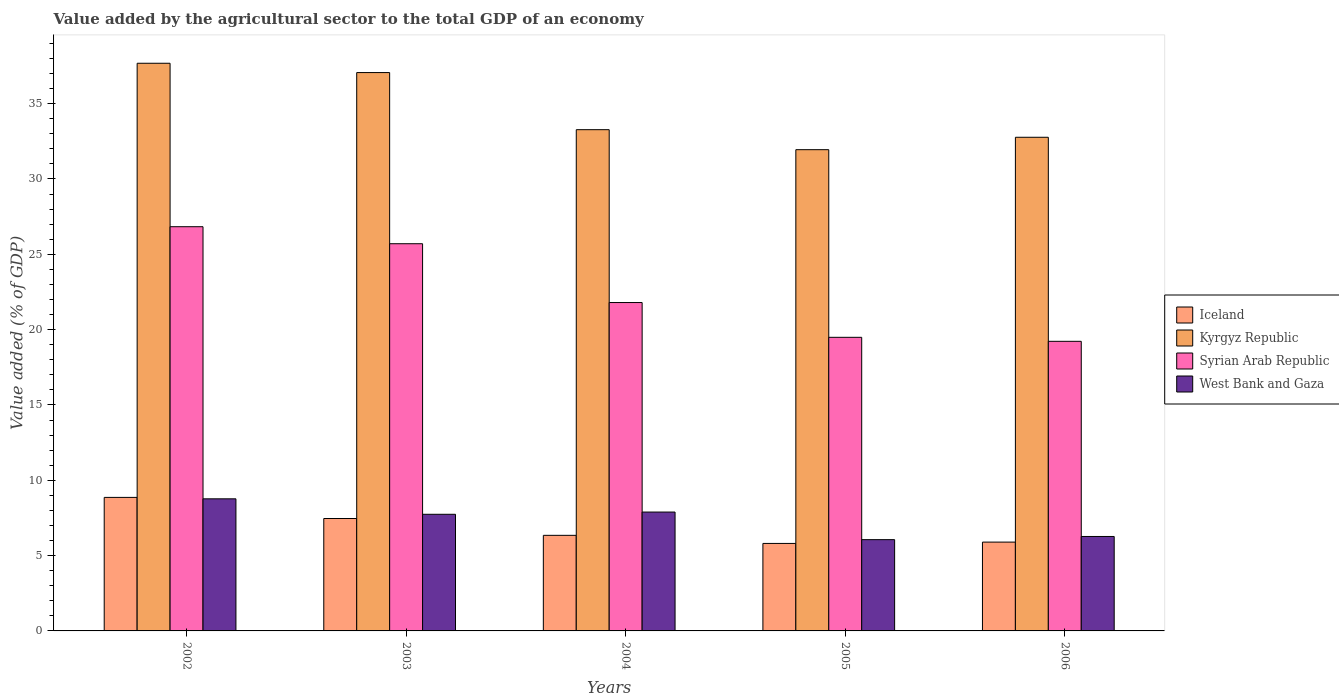How many different coloured bars are there?
Provide a short and direct response. 4. Are the number of bars per tick equal to the number of legend labels?
Make the answer very short. Yes. How many bars are there on the 3rd tick from the right?
Give a very brief answer. 4. What is the label of the 3rd group of bars from the left?
Offer a very short reply. 2004. What is the value added by the agricultural sector to the total GDP in Iceland in 2002?
Offer a terse response. 8.86. Across all years, what is the maximum value added by the agricultural sector to the total GDP in Iceland?
Give a very brief answer. 8.86. Across all years, what is the minimum value added by the agricultural sector to the total GDP in West Bank and Gaza?
Your answer should be very brief. 6.06. In which year was the value added by the agricultural sector to the total GDP in Syrian Arab Republic maximum?
Keep it short and to the point. 2002. What is the total value added by the agricultural sector to the total GDP in Kyrgyz Republic in the graph?
Provide a succinct answer. 172.74. What is the difference between the value added by the agricultural sector to the total GDP in Iceland in 2002 and that in 2003?
Offer a terse response. 1.4. What is the difference between the value added by the agricultural sector to the total GDP in Kyrgyz Republic in 2003 and the value added by the agricultural sector to the total GDP in Syrian Arab Republic in 2004?
Offer a very short reply. 15.27. What is the average value added by the agricultural sector to the total GDP in West Bank and Gaza per year?
Your answer should be very brief. 7.35. In the year 2004, what is the difference between the value added by the agricultural sector to the total GDP in Kyrgyz Republic and value added by the agricultural sector to the total GDP in Syrian Arab Republic?
Offer a very short reply. 11.47. In how many years, is the value added by the agricultural sector to the total GDP in Iceland greater than 3 %?
Offer a very short reply. 5. What is the ratio of the value added by the agricultural sector to the total GDP in Iceland in 2002 to that in 2006?
Make the answer very short. 1.5. Is the difference between the value added by the agricultural sector to the total GDP in Kyrgyz Republic in 2003 and 2006 greater than the difference between the value added by the agricultural sector to the total GDP in Syrian Arab Republic in 2003 and 2006?
Provide a short and direct response. No. What is the difference between the highest and the second highest value added by the agricultural sector to the total GDP in Syrian Arab Republic?
Your answer should be very brief. 1.13. What is the difference between the highest and the lowest value added by the agricultural sector to the total GDP in West Bank and Gaza?
Provide a succinct answer. 2.71. In how many years, is the value added by the agricultural sector to the total GDP in Iceland greater than the average value added by the agricultural sector to the total GDP in Iceland taken over all years?
Give a very brief answer. 2. What does the 3rd bar from the left in 2006 represents?
Provide a short and direct response. Syrian Arab Republic. Is it the case that in every year, the sum of the value added by the agricultural sector to the total GDP in Iceland and value added by the agricultural sector to the total GDP in Kyrgyz Republic is greater than the value added by the agricultural sector to the total GDP in Syrian Arab Republic?
Give a very brief answer. Yes. How many bars are there?
Your answer should be compact. 20. Are all the bars in the graph horizontal?
Offer a very short reply. No. How many years are there in the graph?
Offer a terse response. 5. Does the graph contain any zero values?
Provide a succinct answer. No. Does the graph contain grids?
Ensure brevity in your answer.  No. How many legend labels are there?
Offer a terse response. 4. What is the title of the graph?
Your answer should be compact. Value added by the agricultural sector to the total GDP of an economy. What is the label or title of the X-axis?
Ensure brevity in your answer.  Years. What is the label or title of the Y-axis?
Provide a short and direct response. Value added (% of GDP). What is the Value added (% of GDP) in Iceland in 2002?
Provide a succinct answer. 8.86. What is the Value added (% of GDP) of Kyrgyz Republic in 2002?
Offer a very short reply. 37.68. What is the Value added (% of GDP) of Syrian Arab Republic in 2002?
Provide a succinct answer. 26.83. What is the Value added (% of GDP) of West Bank and Gaza in 2002?
Offer a terse response. 8.77. What is the Value added (% of GDP) of Iceland in 2003?
Keep it short and to the point. 7.46. What is the Value added (% of GDP) in Kyrgyz Republic in 2003?
Your answer should be compact. 37.06. What is the Value added (% of GDP) in Syrian Arab Republic in 2003?
Your response must be concise. 25.7. What is the Value added (% of GDP) of West Bank and Gaza in 2003?
Your answer should be compact. 7.74. What is the Value added (% of GDP) of Iceland in 2004?
Offer a terse response. 6.35. What is the Value added (% of GDP) of Kyrgyz Republic in 2004?
Your answer should be very brief. 33.27. What is the Value added (% of GDP) of Syrian Arab Republic in 2004?
Offer a very short reply. 21.8. What is the Value added (% of GDP) in West Bank and Gaza in 2004?
Your response must be concise. 7.89. What is the Value added (% of GDP) of Iceland in 2005?
Your answer should be compact. 5.81. What is the Value added (% of GDP) of Kyrgyz Republic in 2005?
Keep it short and to the point. 31.95. What is the Value added (% of GDP) in Syrian Arab Republic in 2005?
Make the answer very short. 19.49. What is the Value added (% of GDP) in West Bank and Gaza in 2005?
Offer a terse response. 6.06. What is the Value added (% of GDP) in Iceland in 2006?
Give a very brief answer. 5.9. What is the Value added (% of GDP) in Kyrgyz Republic in 2006?
Your answer should be very brief. 32.77. What is the Value added (% of GDP) of Syrian Arab Republic in 2006?
Offer a terse response. 19.22. What is the Value added (% of GDP) of West Bank and Gaza in 2006?
Provide a succinct answer. 6.27. Across all years, what is the maximum Value added (% of GDP) in Iceland?
Offer a terse response. 8.86. Across all years, what is the maximum Value added (% of GDP) in Kyrgyz Republic?
Keep it short and to the point. 37.68. Across all years, what is the maximum Value added (% of GDP) in Syrian Arab Republic?
Keep it short and to the point. 26.83. Across all years, what is the maximum Value added (% of GDP) of West Bank and Gaza?
Provide a short and direct response. 8.77. Across all years, what is the minimum Value added (% of GDP) of Iceland?
Make the answer very short. 5.81. Across all years, what is the minimum Value added (% of GDP) in Kyrgyz Republic?
Keep it short and to the point. 31.95. Across all years, what is the minimum Value added (% of GDP) of Syrian Arab Republic?
Ensure brevity in your answer.  19.22. Across all years, what is the minimum Value added (% of GDP) in West Bank and Gaza?
Offer a very short reply. 6.06. What is the total Value added (% of GDP) of Iceland in the graph?
Offer a terse response. 34.38. What is the total Value added (% of GDP) of Kyrgyz Republic in the graph?
Keep it short and to the point. 172.74. What is the total Value added (% of GDP) in Syrian Arab Republic in the graph?
Provide a short and direct response. 113.05. What is the total Value added (% of GDP) in West Bank and Gaza in the graph?
Provide a succinct answer. 36.73. What is the difference between the Value added (% of GDP) of Iceland in 2002 and that in 2003?
Offer a very short reply. 1.4. What is the difference between the Value added (% of GDP) of Kyrgyz Republic in 2002 and that in 2003?
Your answer should be very brief. 0.62. What is the difference between the Value added (% of GDP) of Syrian Arab Republic in 2002 and that in 2003?
Provide a succinct answer. 1.13. What is the difference between the Value added (% of GDP) in West Bank and Gaza in 2002 and that in 2003?
Give a very brief answer. 1.03. What is the difference between the Value added (% of GDP) of Iceland in 2002 and that in 2004?
Make the answer very short. 2.52. What is the difference between the Value added (% of GDP) in Kyrgyz Republic in 2002 and that in 2004?
Make the answer very short. 4.41. What is the difference between the Value added (% of GDP) of Syrian Arab Republic in 2002 and that in 2004?
Keep it short and to the point. 5.03. What is the difference between the Value added (% of GDP) in West Bank and Gaza in 2002 and that in 2004?
Provide a short and direct response. 0.88. What is the difference between the Value added (% of GDP) in Iceland in 2002 and that in 2005?
Ensure brevity in your answer.  3.06. What is the difference between the Value added (% of GDP) of Kyrgyz Republic in 2002 and that in 2005?
Ensure brevity in your answer.  5.74. What is the difference between the Value added (% of GDP) of Syrian Arab Republic in 2002 and that in 2005?
Offer a terse response. 7.34. What is the difference between the Value added (% of GDP) in West Bank and Gaza in 2002 and that in 2005?
Offer a very short reply. 2.71. What is the difference between the Value added (% of GDP) of Iceland in 2002 and that in 2006?
Keep it short and to the point. 2.97. What is the difference between the Value added (% of GDP) in Kyrgyz Republic in 2002 and that in 2006?
Your answer should be very brief. 4.91. What is the difference between the Value added (% of GDP) of Syrian Arab Republic in 2002 and that in 2006?
Offer a terse response. 7.61. What is the difference between the Value added (% of GDP) in West Bank and Gaza in 2002 and that in 2006?
Give a very brief answer. 2.5. What is the difference between the Value added (% of GDP) of Iceland in 2003 and that in 2004?
Provide a succinct answer. 1.12. What is the difference between the Value added (% of GDP) in Kyrgyz Republic in 2003 and that in 2004?
Offer a very short reply. 3.79. What is the difference between the Value added (% of GDP) in Syrian Arab Republic in 2003 and that in 2004?
Offer a terse response. 3.9. What is the difference between the Value added (% of GDP) of West Bank and Gaza in 2003 and that in 2004?
Your response must be concise. -0.15. What is the difference between the Value added (% of GDP) in Iceland in 2003 and that in 2005?
Keep it short and to the point. 1.65. What is the difference between the Value added (% of GDP) of Kyrgyz Republic in 2003 and that in 2005?
Ensure brevity in your answer.  5.12. What is the difference between the Value added (% of GDP) of Syrian Arab Republic in 2003 and that in 2005?
Your answer should be very brief. 6.21. What is the difference between the Value added (% of GDP) of West Bank and Gaza in 2003 and that in 2005?
Your answer should be compact. 1.68. What is the difference between the Value added (% of GDP) in Iceland in 2003 and that in 2006?
Ensure brevity in your answer.  1.57. What is the difference between the Value added (% of GDP) in Kyrgyz Republic in 2003 and that in 2006?
Provide a short and direct response. 4.29. What is the difference between the Value added (% of GDP) in Syrian Arab Republic in 2003 and that in 2006?
Your answer should be very brief. 6.48. What is the difference between the Value added (% of GDP) of West Bank and Gaza in 2003 and that in 2006?
Keep it short and to the point. 1.47. What is the difference between the Value added (% of GDP) of Iceland in 2004 and that in 2005?
Your response must be concise. 0.54. What is the difference between the Value added (% of GDP) in Kyrgyz Republic in 2004 and that in 2005?
Make the answer very short. 1.33. What is the difference between the Value added (% of GDP) in Syrian Arab Republic in 2004 and that in 2005?
Give a very brief answer. 2.31. What is the difference between the Value added (% of GDP) in West Bank and Gaza in 2004 and that in 2005?
Provide a succinct answer. 1.83. What is the difference between the Value added (% of GDP) in Iceland in 2004 and that in 2006?
Offer a very short reply. 0.45. What is the difference between the Value added (% of GDP) in Kyrgyz Republic in 2004 and that in 2006?
Ensure brevity in your answer.  0.5. What is the difference between the Value added (% of GDP) in Syrian Arab Republic in 2004 and that in 2006?
Your answer should be compact. 2.57. What is the difference between the Value added (% of GDP) of West Bank and Gaza in 2004 and that in 2006?
Ensure brevity in your answer.  1.62. What is the difference between the Value added (% of GDP) of Iceland in 2005 and that in 2006?
Provide a short and direct response. -0.09. What is the difference between the Value added (% of GDP) of Kyrgyz Republic in 2005 and that in 2006?
Offer a terse response. -0.82. What is the difference between the Value added (% of GDP) in Syrian Arab Republic in 2005 and that in 2006?
Your response must be concise. 0.26. What is the difference between the Value added (% of GDP) of West Bank and Gaza in 2005 and that in 2006?
Offer a terse response. -0.21. What is the difference between the Value added (% of GDP) of Iceland in 2002 and the Value added (% of GDP) of Kyrgyz Republic in 2003?
Your answer should be compact. -28.2. What is the difference between the Value added (% of GDP) of Iceland in 2002 and the Value added (% of GDP) of Syrian Arab Republic in 2003?
Your response must be concise. -16.84. What is the difference between the Value added (% of GDP) of Iceland in 2002 and the Value added (% of GDP) of West Bank and Gaza in 2003?
Offer a very short reply. 1.12. What is the difference between the Value added (% of GDP) of Kyrgyz Republic in 2002 and the Value added (% of GDP) of Syrian Arab Republic in 2003?
Keep it short and to the point. 11.98. What is the difference between the Value added (% of GDP) of Kyrgyz Republic in 2002 and the Value added (% of GDP) of West Bank and Gaza in 2003?
Keep it short and to the point. 29.94. What is the difference between the Value added (% of GDP) of Syrian Arab Republic in 2002 and the Value added (% of GDP) of West Bank and Gaza in 2003?
Keep it short and to the point. 19.09. What is the difference between the Value added (% of GDP) of Iceland in 2002 and the Value added (% of GDP) of Kyrgyz Republic in 2004?
Make the answer very short. -24.41. What is the difference between the Value added (% of GDP) of Iceland in 2002 and the Value added (% of GDP) of Syrian Arab Republic in 2004?
Provide a short and direct response. -12.94. What is the difference between the Value added (% of GDP) in Iceland in 2002 and the Value added (% of GDP) in West Bank and Gaza in 2004?
Ensure brevity in your answer.  0.97. What is the difference between the Value added (% of GDP) in Kyrgyz Republic in 2002 and the Value added (% of GDP) in Syrian Arab Republic in 2004?
Your response must be concise. 15.88. What is the difference between the Value added (% of GDP) of Kyrgyz Republic in 2002 and the Value added (% of GDP) of West Bank and Gaza in 2004?
Ensure brevity in your answer.  29.79. What is the difference between the Value added (% of GDP) in Syrian Arab Republic in 2002 and the Value added (% of GDP) in West Bank and Gaza in 2004?
Make the answer very short. 18.94. What is the difference between the Value added (% of GDP) of Iceland in 2002 and the Value added (% of GDP) of Kyrgyz Republic in 2005?
Your response must be concise. -23.08. What is the difference between the Value added (% of GDP) of Iceland in 2002 and the Value added (% of GDP) of Syrian Arab Republic in 2005?
Offer a very short reply. -10.63. What is the difference between the Value added (% of GDP) in Iceland in 2002 and the Value added (% of GDP) in West Bank and Gaza in 2005?
Your answer should be very brief. 2.8. What is the difference between the Value added (% of GDP) of Kyrgyz Republic in 2002 and the Value added (% of GDP) of Syrian Arab Republic in 2005?
Your response must be concise. 18.19. What is the difference between the Value added (% of GDP) of Kyrgyz Republic in 2002 and the Value added (% of GDP) of West Bank and Gaza in 2005?
Provide a short and direct response. 31.62. What is the difference between the Value added (% of GDP) of Syrian Arab Republic in 2002 and the Value added (% of GDP) of West Bank and Gaza in 2005?
Offer a terse response. 20.77. What is the difference between the Value added (% of GDP) of Iceland in 2002 and the Value added (% of GDP) of Kyrgyz Republic in 2006?
Give a very brief answer. -23.91. What is the difference between the Value added (% of GDP) in Iceland in 2002 and the Value added (% of GDP) in Syrian Arab Republic in 2006?
Provide a short and direct response. -10.36. What is the difference between the Value added (% of GDP) in Iceland in 2002 and the Value added (% of GDP) in West Bank and Gaza in 2006?
Your answer should be compact. 2.59. What is the difference between the Value added (% of GDP) in Kyrgyz Republic in 2002 and the Value added (% of GDP) in Syrian Arab Republic in 2006?
Keep it short and to the point. 18.46. What is the difference between the Value added (% of GDP) of Kyrgyz Republic in 2002 and the Value added (% of GDP) of West Bank and Gaza in 2006?
Give a very brief answer. 31.41. What is the difference between the Value added (% of GDP) in Syrian Arab Republic in 2002 and the Value added (% of GDP) in West Bank and Gaza in 2006?
Your answer should be very brief. 20.56. What is the difference between the Value added (% of GDP) of Iceland in 2003 and the Value added (% of GDP) of Kyrgyz Republic in 2004?
Keep it short and to the point. -25.81. What is the difference between the Value added (% of GDP) in Iceland in 2003 and the Value added (% of GDP) in Syrian Arab Republic in 2004?
Your answer should be very brief. -14.34. What is the difference between the Value added (% of GDP) of Iceland in 2003 and the Value added (% of GDP) of West Bank and Gaza in 2004?
Your response must be concise. -0.43. What is the difference between the Value added (% of GDP) in Kyrgyz Republic in 2003 and the Value added (% of GDP) in Syrian Arab Republic in 2004?
Your answer should be very brief. 15.27. What is the difference between the Value added (% of GDP) of Kyrgyz Republic in 2003 and the Value added (% of GDP) of West Bank and Gaza in 2004?
Provide a short and direct response. 29.17. What is the difference between the Value added (% of GDP) of Syrian Arab Republic in 2003 and the Value added (% of GDP) of West Bank and Gaza in 2004?
Ensure brevity in your answer.  17.81. What is the difference between the Value added (% of GDP) of Iceland in 2003 and the Value added (% of GDP) of Kyrgyz Republic in 2005?
Your answer should be compact. -24.48. What is the difference between the Value added (% of GDP) in Iceland in 2003 and the Value added (% of GDP) in Syrian Arab Republic in 2005?
Provide a short and direct response. -12.03. What is the difference between the Value added (% of GDP) in Iceland in 2003 and the Value added (% of GDP) in West Bank and Gaza in 2005?
Offer a terse response. 1.4. What is the difference between the Value added (% of GDP) in Kyrgyz Republic in 2003 and the Value added (% of GDP) in Syrian Arab Republic in 2005?
Offer a terse response. 17.57. What is the difference between the Value added (% of GDP) in Kyrgyz Republic in 2003 and the Value added (% of GDP) in West Bank and Gaza in 2005?
Provide a short and direct response. 31.01. What is the difference between the Value added (% of GDP) in Syrian Arab Republic in 2003 and the Value added (% of GDP) in West Bank and Gaza in 2005?
Your answer should be very brief. 19.64. What is the difference between the Value added (% of GDP) of Iceland in 2003 and the Value added (% of GDP) of Kyrgyz Republic in 2006?
Ensure brevity in your answer.  -25.31. What is the difference between the Value added (% of GDP) in Iceland in 2003 and the Value added (% of GDP) in Syrian Arab Republic in 2006?
Offer a very short reply. -11.76. What is the difference between the Value added (% of GDP) of Iceland in 2003 and the Value added (% of GDP) of West Bank and Gaza in 2006?
Ensure brevity in your answer.  1.19. What is the difference between the Value added (% of GDP) of Kyrgyz Republic in 2003 and the Value added (% of GDP) of Syrian Arab Republic in 2006?
Ensure brevity in your answer.  17.84. What is the difference between the Value added (% of GDP) in Kyrgyz Republic in 2003 and the Value added (% of GDP) in West Bank and Gaza in 2006?
Provide a succinct answer. 30.79. What is the difference between the Value added (% of GDP) in Syrian Arab Republic in 2003 and the Value added (% of GDP) in West Bank and Gaza in 2006?
Your answer should be compact. 19.43. What is the difference between the Value added (% of GDP) of Iceland in 2004 and the Value added (% of GDP) of Kyrgyz Republic in 2005?
Provide a short and direct response. -25.6. What is the difference between the Value added (% of GDP) in Iceland in 2004 and the Value added (% of GDP) in Syrian Arab Republic in 2005?
Your answer should be very brief. -13.14. What is the difference between the Value added (% of GDP) in Iceland in 2004 and the Value added (% of GDP) in West Bank and Gaza in 2005?
Make the answer very short. 0.29. What is the difference between the Value added (% of GDP) of Kyrgyz Republic in 2004 and the Value added (% of GDP) of Syrian Arab Republic in 2005?
Give a very brief answer. 13.78. What is the difference between the Value added (% of GDP) of Kyrgyz Republic in 2004 and the Value added (% of GDP) of West Bank and Gaza in 2005?
Your answer should be compact. 27.21. What is the difference between the Value added (% of GDP) of Syrian Arab Republic in 2004 and the Value added (% of GDP) of West Bank and Gaza in 2005?
Make the answer very short. 15.74. What is the difference between the Value added (% of GDP) of Iceland in 2004 and the Value added (% of GDP) of Kyrgyz Republic in 2006?
Offer a very short reply. -26.42. What is the difference between the Value added (% of GDP) in Iceland in 2004 and the Value added (% of GDP) in Syrian Arab Republic in 2006?
Provide a short and direct response. -12.88. What is the difference between the Value added (% of GDP) of Iceland in 2004 and the Value added (% of GDP) of West Bank and Gaza in 2006?
Your answer should be compact. 0.08. What is the difference between the Value added (% of GDP) in Kyrgyz Republic in 2004 and the Value added (% of GDP) in Syrian Arab Republic in 2006?
Ensure brevity in your answer.  14.05. What is the difference between the Value added (% of GDP) in Kyrgyz Republic in 2004 and the Value added (% of GDP) in West Bank and Gaza in 2006?
Make the answer very short. 27. What is the difference between the Value added (% of GDP) of Syrian Arab Republic in 2004 and the Value added (% of GDP) of West Bank and Gaza in 2006?
Provide a succinct answer. 15.53. What is the difference between the Value added (% of GDP) in Iceland in 2005 and the Value added (% of GDP) in Kyrgyz Republic in 2006?
Make the answer very short. -26.96. What is the difference between the Value added (% of GDP) of Iceland in 2005 and the Value added (% of GDP) of Syrian Arab Republic in 2006?
Provide a short and direct response. -13.42. What is the difference between the Value added (% of GDP) of Iceland in 2005 and the Value added (% of GDP) of West Bank and Gaza in 2006?
Offer a terse response. -0.46. What is the difference between the Value added (% of GDP) in Kyrgyz Republic in 2005 and the Value added (% of GDP) in Syrian Arab Republic in 2006?
Provide a succinct answer. 12.72. What is the difference between the Value added (% of GDP) in Kyrgyz Republic in 2005 and the Value added (% of GDP) in West Bank and Gaza in 2006?
Make the answer very short. 25.68. What is the difference between the Value added (% of GDP) of Syrian Arab Republic in 2005 and the Value added (% of GDP) of West Bank and Gaza in 2006?
Ensure brevity in your answer.  13.22. What is the average Value added (% of GDP) of Iceland per year?
Your response must be concise. 6.88. What is the average Value added (% of GDP) of Kyrgyz Republic per year?
Make the answer very short. 34.55. What is the average Value added (% of GDP) in Syrian Arab Republic per year?
Your answer should be compact. 22.61. What is the average Value added (% of GDP) of West Bank and Gaza per year?
Ensure brevity in your answer.  7.35. In the year 2002, what is the difference between the Value added (% of GDP) of Iceland and Value added (% of GDP) of Kyrgyz Republic?
Make the answer very short. -28.82. In the year 2002, what is the difference between the Value added (% of GDP) in Iceland and Value added (% of GDP) in Syrian Arab Republic?
Offer a terse response. -17.97. In the year 2002, what is the difference between the Value added (% of GDP) of Iceland and Value added (% of GDP) of West Bank and Gaza?
Offer a very short reply. 0.09. In the year 2002, what is the difference between the Value added (% of GDP) of Kyrgyz Republic and Value added (% of GDP) of Syrian Arab Republic?
Ensure brevity in your answer.  10.85. In the year 2002, what is the difference between the Value added (% of GDP) in Kyrgyz Republic and Value added (% of GDP) in West Bank and Gaza?
Provide a short and direct response. 28.91. In the year 2002, what is the difference between the Value added (% of GDP) in Syrian Arab Republic and Value added (% of GDP) in West Bank and Gaza?
Your answer should be very brief. 18.06. In the year 2003, what is the difference between the Value added (% of GDP) in Iceland and Value added (% of GDP) in Kyrgyz Republic?
Your response must be concise. -29.6. In the year 2003, what is the difference between the Value added (% of GDP) of Iceland and Value added (% of GDP) of Syrian Arab Republic?
Keep it short and to the point. -18.24. In the year 2003, what is the difference between the Value added (% of GDP) of Iceland and Value added (% of GDP) of West Bank and Gaza?
Keep it short and to the point. -0.28. In the year 2003, what is the difference between the Value added (% of GDP) of Kyrgyz Republic and Value added (% of GDP) of Syrian Arab Republic?
Your answer should be compact. 11.36. In the year 2003, what is the difference between the Value added (% of GDP) in Kyrgyz Republic and Value added (% of GDP) in West Bank and Gaza?
Provide a succinct answer. 29.32. In the year 2003, what is the difference between the Value added (% of GDP) of Syrian Arab Republic and Value added (% of GDP) of West Bank and Gaza?
Provide a short and direct response. 17.96. In the year 2004, what is the difference between the Value added (% of GDP) of Iceland and Value added (% of GDP) of Kyrgyz Republic?
Offer a terse response. -26.93. In the year 2004, what is the difference between the Value added (% of GDP) in Iceland and Value added (% of GDP) in Syrian Arab Republic?
Offer a very short reply. -15.45. In the year 2004, what is the difference between the Value added (% of GDP) in Iceland and Value added (% of GDP) in West Bank and Gaza?
Your answer should be compact. -1.55. In the year 2004, what is the difference between the Value added (% of GDP) in Kyrgyz Republic and Value added (% of GDP) in Syrian Arab Republic?
Ensure brevity in your answer.  11.47. In the year 2004, what is the difference between the Value added (% of GDP) in Kyrgyz Republic and Value added (% of GDP) in West Bank and Gaza?
Provide a succinct answer. 25.38. In the year 2004, what is the difference between the Value added (% of GDP) of Syrian Arab Republic and Value added (% of GDP) of West Bank and Gaza?
Provide a succinct answer. 13.91. In the year 2005, what is the difference between the Value added (% of GDP) of Iceland and Value added (% of GDP) of Kyrgyz Republic?
Your answer should be very brief. -26.14. In the year 2005, what is the difference between the Value added (% of GDP) of Iceland and Value added (% of GDP) of Syrian Arab Republic?
Offer a terse response. -13.68. In the year 2005, what is the difference between the Value added (% of GDP) in Iceland and Value added (% of GDP) in West Bank and Gaza?
Your answer should be compact. -0.25. In the year 2005, what is the difference between the Value added (% of GDP) of Kyrgyz Republic and Value added (% of GDP) of Syrian Arab Republic?
Your response must be concise. 12.46. In the year 2005, what is the difference between the Value added (% of GDP) of Kyrgyz Republic and Value added (% of GDP) of West Bank and Gaza?
Offer a terse response. 25.89. In the year 2005, what is the difference between the Value added (% of GDP) of Syrian Arab Republic and Value added (% of GDP) of West Bank and Gaza?
Make the answer very short. 13.43. In the year 2006, what is the difference between the Value added (% of GDP) of Iceland and Value added (% of GDP) of Kyrgyz Republic?
Ensure brevity in your answer.  -26.87. In the year 2006, what is the difference between the Value added (% of GDP) in Iceland and Value added (% of GDP) in Syrian Arab Republic?
Provide a short and direct response. -13.33. In the year 2006, what is the difference between the Value added (% of GDP) in Iceland and Value added (% of GDP) in West Bank and Gaza?
Your answer should be compact. -0.37. In the year 2006, what is the difference between the Value added (% of GDP) in Kyrgyz Republic and Value added (% of GDP) in Syrian Arab Republic?
Keep it short and to the point. 13.55. In the year 2006, what is the difference between the Value added (% of GDP) in Kyrgyz Republic and Value added (% of GDP) in West Bank and Gaza?
Provide a short and direct response. 26.5. In the year 2006, what is the difference between the Value added (% of GDP) in Syrian Arab Republic and Value added (% of GDP) in West Bank and Gaza?
Make the answer very short. 12.96. What is the ratio of the Value added (% of GDP) in Iceland in 2002 to that in 2003?
Make the answer very short. 1.19. What is the ratio of the Value added (% of GDP) in Kyrgyz Republic in 2002 to that in 2003?
Offer a very short reply. 1.02. What is the ratio of the Value added (% of GDP) in Syrian Arab Republic in 2002 to that in 2003?
Your response must be concise. 1.04. What is the ratio of the Value added (% of GDP) of West Bank and Gaza in 2002 to that in 2003?
Offer a very short reply. 1.13. What is the ratio of the Value added (% of GDP) in Iceland in 2002 to that in 2004?
Ensure brevity in your answer.  1.4. What is the ratio of the Value added (% of GDP) in Kyrgyz Republic in 2002 to that in 2004?
Your answer should be very brief. 1.13. What is the ratio of the Value added (% of GDP) in Syrian Arab Republic in 2002 to that in 2004?
Offer a terse response. 1.23. What is the ratio of the Value added (% of GDP) of West Bank and Gaza in 2002 to that in 2004?
Keep it short and to the point. 1.11. What is the ratio of the Value added (% of GDP) in Iceland in 2002 to that in 2005?
Offer a terse response. 1.53. What is the ratio of the Value added (% of GDP) of Kyrgyz Republic in 2002 to that in 2005?
Your answer should be very brief. 1.18. What is the ratio of the Value added (% of GDP) in Syrian Arab Republic in 2002 to that in 2005?
Keep it short and to the point. 1.38. What is the ratio of the Value added (% of GDP) of West Bank and Gaza in 2002 to that in 2005?
Offer a terse response. 1.45. What is the ratio of the Value added (% of GDP) of Iceland in 2002 to that in 2006?
Your response must be concise. 1.5. What is the ratio of the Value added (% of GDP) of Kyrgyz Republic in 2002 to that in 2006?
Give a very brief answer. 1.15. What is the ratio of the Value added (% of GDP) of Syrian Arab Republic in 2002 to that in 2006?
Provide a short and direct response. 1.4. What is the ratio of the Value added (% of GDP) in West Bank and Gaza in 2002 to that in 2006?
Your answer should be very brief. 1.4. What is the ratio of the Value added (% of GDP) in Iceland in 2003 to that in 2004?
Your response must be concise. 1.18. What is the ratio of the Value added (% of GDP) in Kyrgyz Republic in 2003 to that in 2004?
Your response must be concise. 1.11. What is the ratio of the Value added (% of GDP) of Syrian Arab Republic in 2003 to that in 2004?
Make the answer very short. 1.18. What is the ratio of the Value added (% of GDP) in West Bank and Gaza in 2003 to that in 2004?
Offer a very short reply. 0.98. What is the ratio of the Value added (% of GDP) of Iceland in 2003 to that in 2005?
Your response must be concise. 1.28. What is the ratio of the Value added (% of GDP) of Kyrgyz Republic in 2003 to that in 2005?
Offer a very short reply. 1.16. What is the ratio of the Value added (% of GDP) in Syrian Arab Republic in 2003 to that in 2005?
Your answer should be compact. 1.32. What is the ratio of the Value added (% of GDP) in West Bank and Gaza in 2003 to that in 2005?
Offer a very short reply. 1.28. What is the ratio of the Value added (% of GDP) in Iceland in 2003 to that in 2006?
Your response must be concise. 1.27. What is the ratio of the Value added (% of GDP) of Kyrgyz Republic in 2003 to that in 2006?
Offer a terse response. 1.13. What is the ratio of the Value added (% of GDP) in Syrian Arab Republic in 2003 to that in 2006?
Provide a succinct answer. 1.34. What is the ratio of the Value added (% of GDP) of West Bank and Gaza in 2003 to that in 2006?
Offer a very short reply. 1.24. What is the ratio of the Value added (% of GDP) of Iceland in 2004 to that in 2005?
Give a very brief answer. 1.09. What is the ratio of the Value added (% of GDP) of Kyrgyz Republic in 2004 to that in 2005?
Provide a short and direct response. 1.04. What is the ratio of the Value added (% of GDP) in Syrian Arab Republic in 2004 to that in 2005?
Provide a short and direct response. 1.12. What is the ratio of the Value added (% of GDP) of West Bank and Gaza in 2004 to that in 2005?
Give a very brief answer. 1.3. What is the ratio of the Value added (% of GDP) in Iceland in 2004 to that in 2006?
Provide a short and direct response. 1.08. What is the ratio of the Value added (% of GDP) in Kyrgyz Republic in 2004 to that in 2006?
Offer a very short reply. 1.02. What is the ratio of the Value added (% of GDP) in Syrian Arab Republic in 2004 to that in 2006?
Your answer should be compact. 1.13. What is the ratio of the Value added (% of GDP) of West Bank and Gaza in 2004 to that in 2006?
Your answer should be very brief. 1.26. What is the ratio of the Value added (% of GDP) in Iceland in 2005 to that in 2006?
Give a very brief answer. 0.98. What is the ratio of the Value added (% of GDP) of Kyrgyz Republic in 2005 to that in 2006?
Offer a very short reply. 0.97. What is the ratio of the Value added (% of GDP) in Syrian Arab Republic in 2005 to that in 2006?
Your answer should be very brief. 1.01. What is the ratio of the Value added (% of GDP) in West Bank and Gaza in 2005 to that in 2006?
Provide a short and direct response. 0.97. What is the difference between the highest and the second highest Value added (% of GDP) of Iceland?
Offer a terse response. 1.4. What is the difference between the highest and the second highest Value added (% of GDP) of Kyrgyz Republic?
Keep it short and to the point. 0.62. What is the difference between the highest and the second highest Value added (% of GDP) in Syrian Arab Republic?
Give a very brief answer. 1.13. What is the difference between the highest and the second highest Value added (% of GDP) of West Bank and Gaza?
Your answer should be compact. 0.88. What is the difference between the highest and the lowest Value added (% of GDP) of Iceland?
Provide a short and direct response. 3.06. What is the difference between the highest and the lowest Value added (% of GDP) of Kyrgyz Republic?
Provide a short and direct response. 5.74. What is the difference between the highest and the lowest Value added (% of GDP) of Syrian Arab Republic?
Offer a terse response. 7.61. What is the difference between the highest and the lowest Value added (% of GDP) of West Bank and Gaza?
Your answer should be compact. 2.71. 